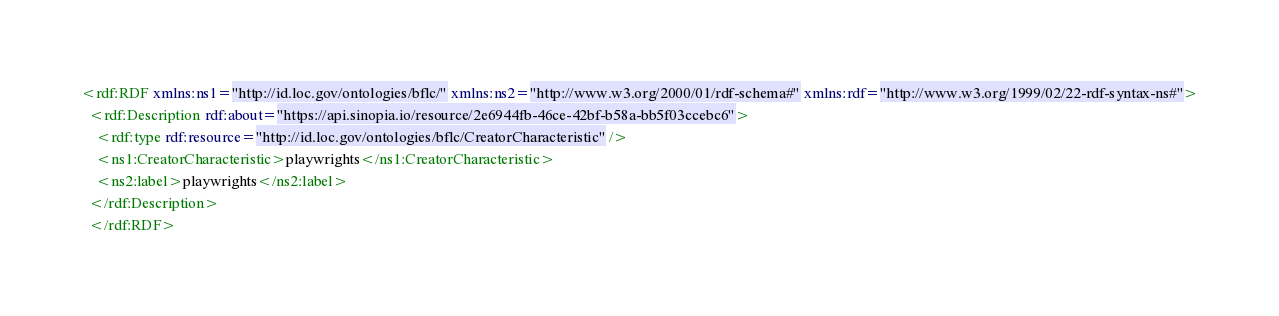Convert code to text. <code><loc_0><loc_0><loc_500><loc_500><_XML_><rdf:RDF xmlns:ns1="http://id.loc.gov/ontologies/bflc/" xmlns:ns2="http://www.w3.org/2000/01/rdf-schema#" xmlns:rdf="http://www.w3.org/1999/02/22-rdf-syntax-ns#">
  <rdf:Description rdf:about="https://api.sinopia.io/resource/2e6944fb-46ce-42bf-b58a-bb5f03ccebc6">
    <rdf:type rdf:resource="http://id.loc.gov/ontologies/bflc/CreatorCharacteristic" />
    <ns1:CreatorCharacteristic>playwrights</ns1:CreatorCharacteristic>
    <ns2:label>playwrights</ns2:label>
  </rdf:Description>
  </rdf:RDF></code> 